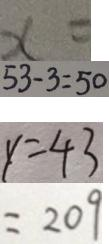<formula> <loc_0><loc_0><loc_500><loc_500>x = 
 5 3 - 3 = 5 0 
 y = 4 3 
 = 2 0 9</formula> 